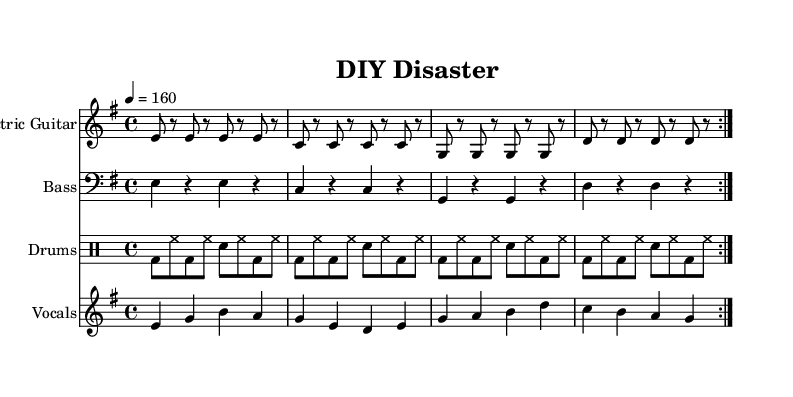What is the key signature of this music? The key signature is indicated at the beginning of the piece, showing that it is in E minor, which has one sharp (F#).
Answer: E minor What is the time signature of the piece? The time signature is also presented at the beginning of the music, indicating it is in 4/4 time, which means there are four beats per measure.
Answer: 4/4 What is the tempo marking for this song? The tempo marking shows that the piece is to be played at 160 beats per minute, indicating a fast pace typical of punk rock.
Answer: 160 How many measures are in the verse section? The verse section is made up of two repeated segments, each containing four measures, resulting in a total of 8 measures.
Answer: 8 What is the starting note of the vocals? The starting note of the vocal melody is E, which can be found at the beginning of the melody staff.
Answer: E What musical genre does this song represent? The song represents the punk rock genre, characterized by its fast tempo and themes of frustration and dissatisfaction, as portrayed in the lyrics.
Answer: Punk rock What instruments are featured in the score? The score lists four distinct instrument parts: Electric Guitar, Bass, Drums, and Vocals, showcasing a typical punk band setup.
Answer: Electric Guitar, Bass, Drums, Vocals 